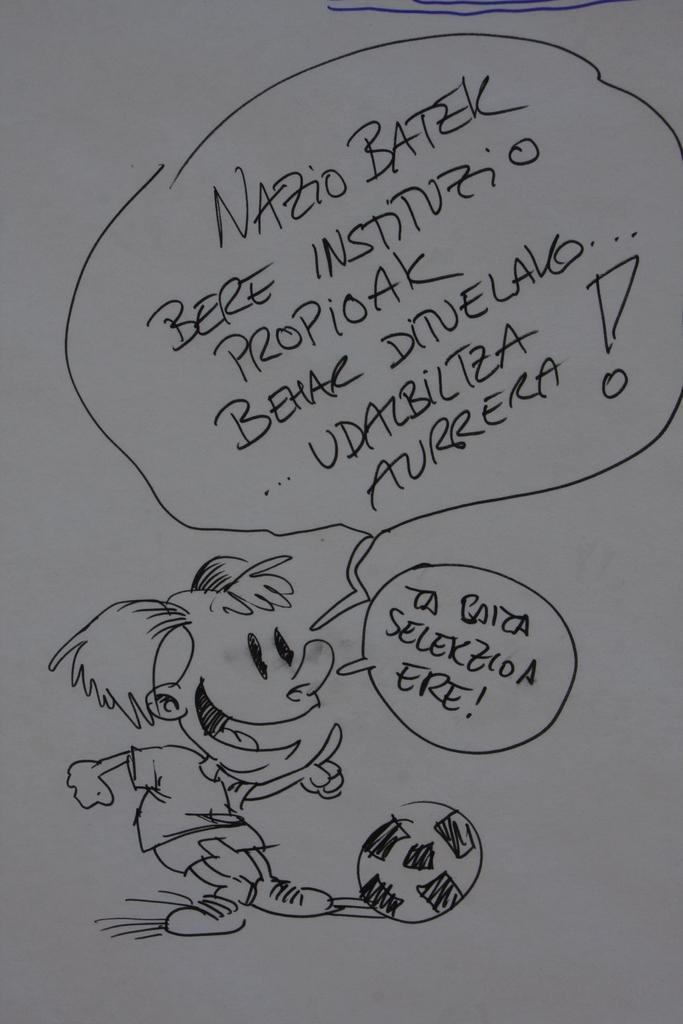What is depicted on the paper in the image? The paper contains a drawing of a ball and a person. What else can be found on the paper besides the drawings? There is text on the paper. How does the person in the drawing breathe in the image? There is no indication of breathing in the image, as it is a drawing on paper. 